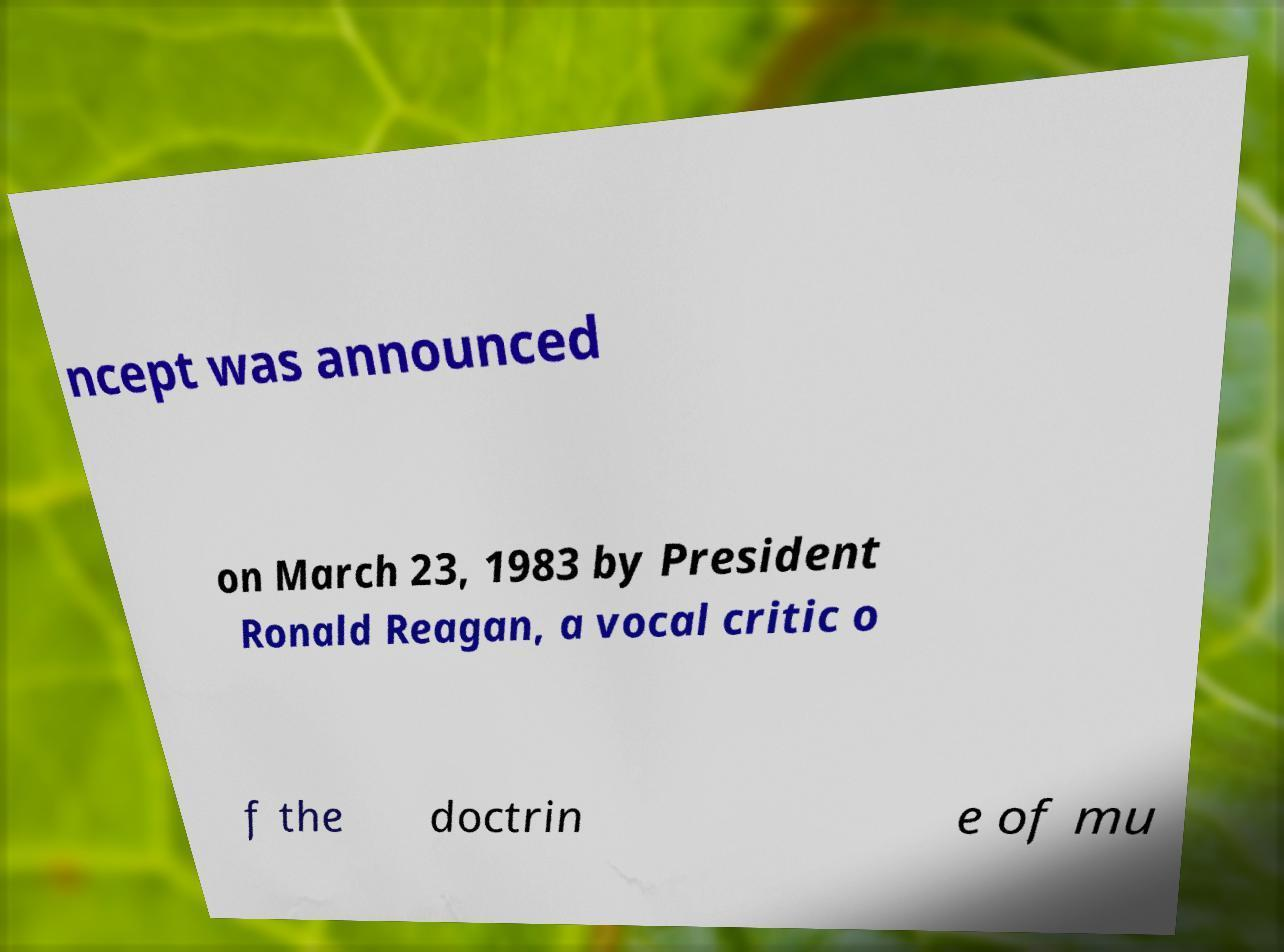Could you extract and type out the text from this image? ncept was announced on March 23, 1983 by President Ronald Reagan, a vocal critic o f the doctrin e of mu 